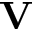<formula> <loc_0><loc_0><loc_500><loc_500>V</formula> 